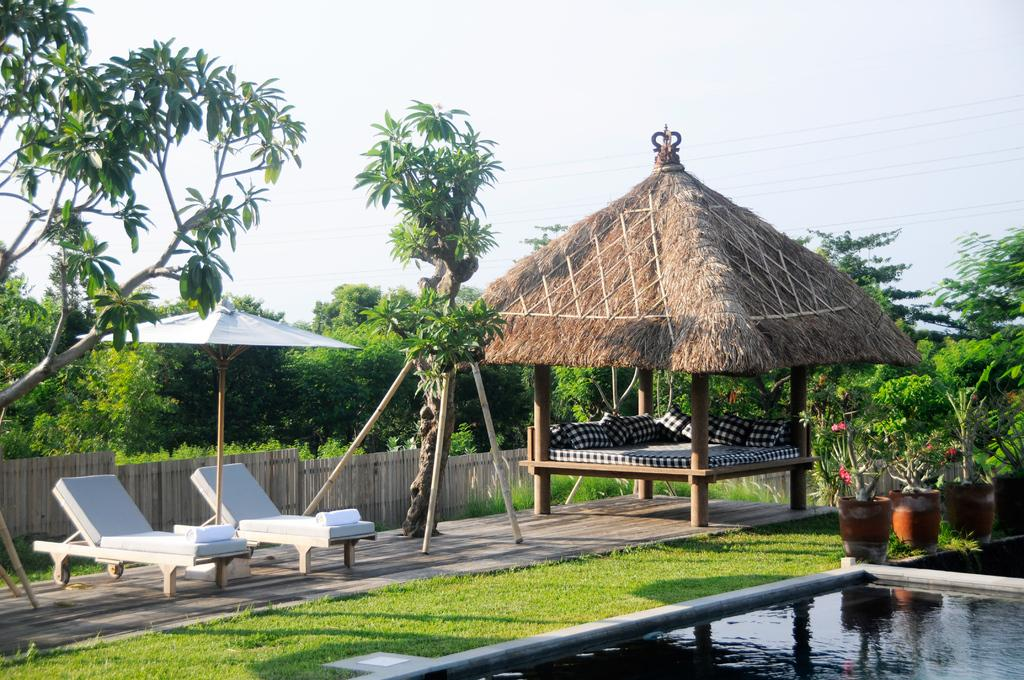What type of furniture is in the image? There are lounge chairs in the image. What can be seen in the background of the image? There are trees and the sky visible in the background of the image. What is the ground surface like in the image? The grass is visible in the image. What is the purpose of the fence in the image? The fence is present in the image, but its purpose is not explicitly stated. What other objects are present in the image? There are flower pots and other objects in the image. What type of protest is taking place in the image? There is no protest present in the image; it features lounge chairs, water, flower pots, a fence, grass, and trees in the background. What type of punishment is being administered in the image? There is no punishment being administered in the image; it features lounge chairs, water, flower pots, a fence, grass, and trees in the background. 